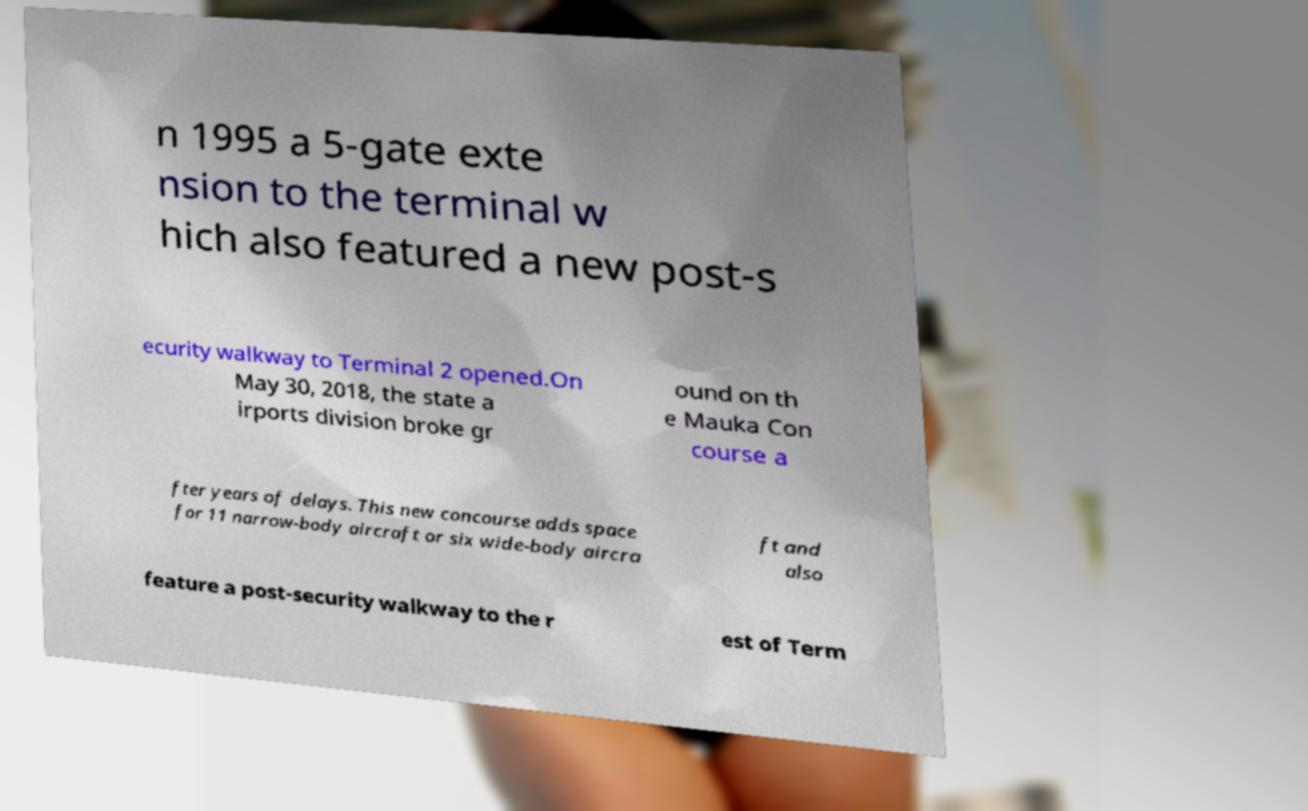Could you extract and type out the text from this image? n 1995 a 5-gate exte nsion to the terminal w hich also featured a new post-s ecurity walkway to Terminal 2 opened.On May 30, 2018, the state a irports division broke gr ound on th e Mauka Con course a fter years of delays. This new concourse adds space for 11 narrow-body aircraft or six wide-body aircra ft and also feature a post-security walkway to the r est of Term 